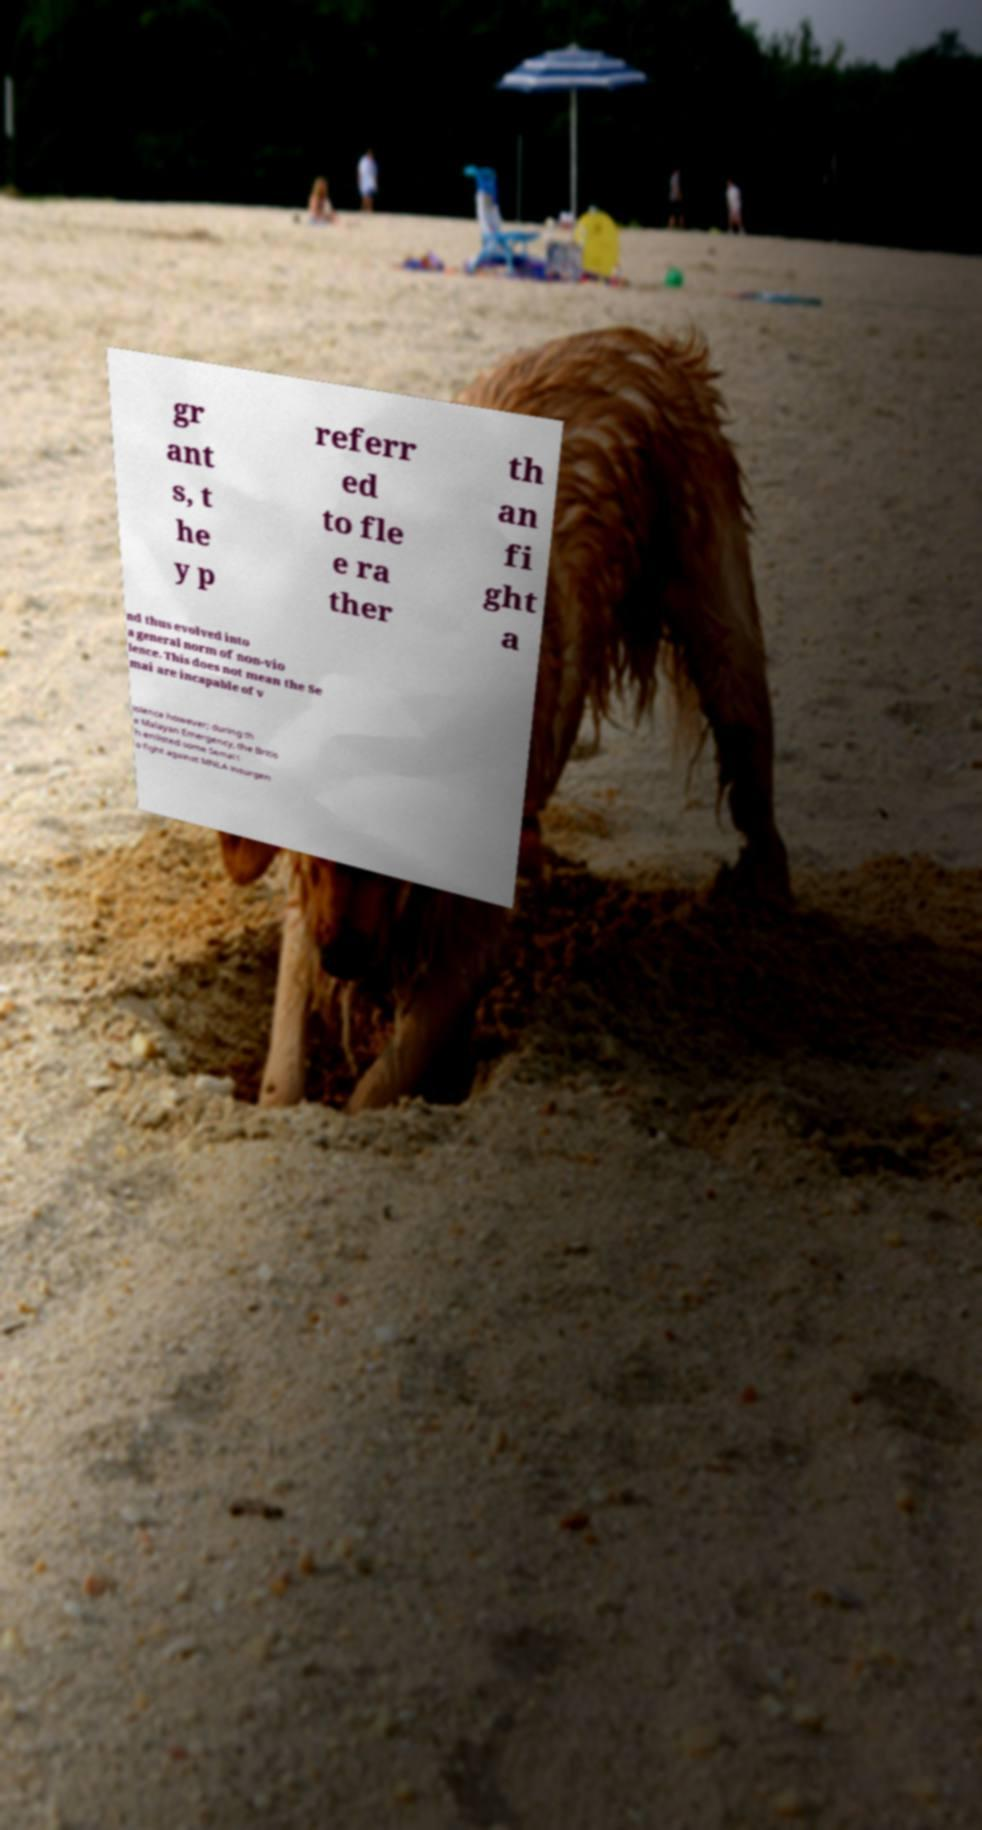Please read and relay the text visible in this image. What does it say? gr ant s, t he y p referr ed to fle e ra ther th an fi ght a nd thus evolved into a general norm of non-vio lence. This does not mean the Se mai are incapable of v iolence however; during th e Malayan Emergency, the Britis h enlisted some Semai t o fight against MNLA insurgen 